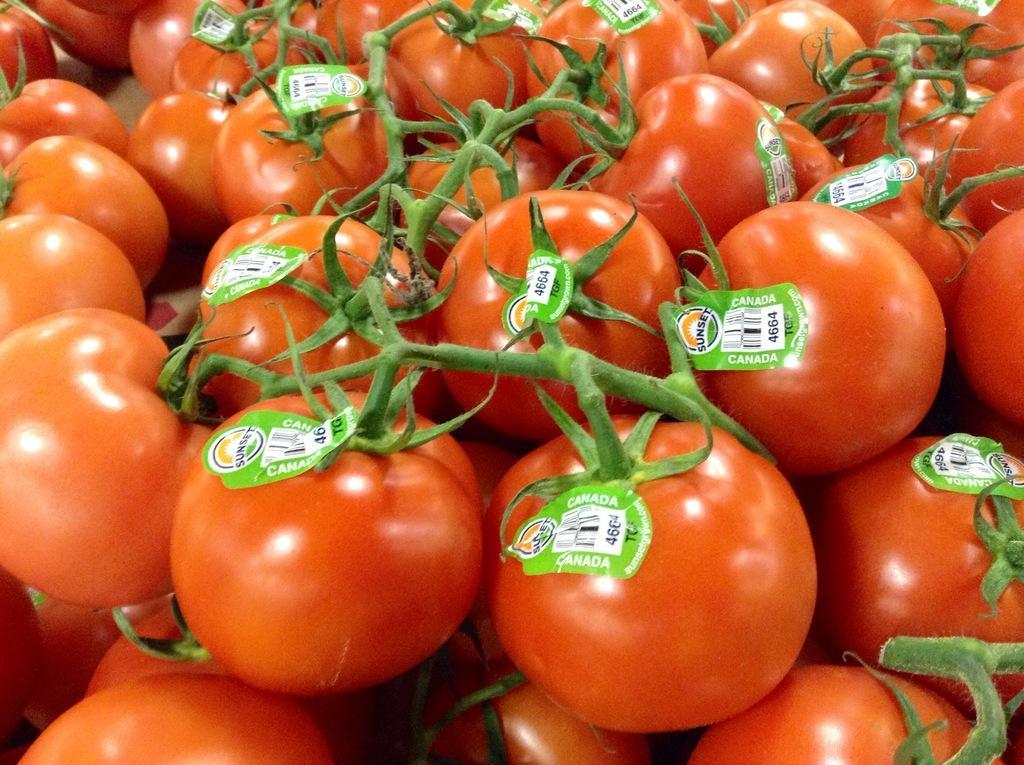Can you describe this image briefly? In the image there are a lot of tomatoes and there are some stickers attached to each tomato. 